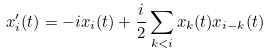<formula> <loc_0><loc_0><loc_500><loc_500>x _ { i } ^ { \prime } ( t ) = - i x _ { i } ( t ) + \frac { i } { 2 } \sum _ { k < i } x _ { k } ( t ) x _ { i - k } ( t )</formula> 